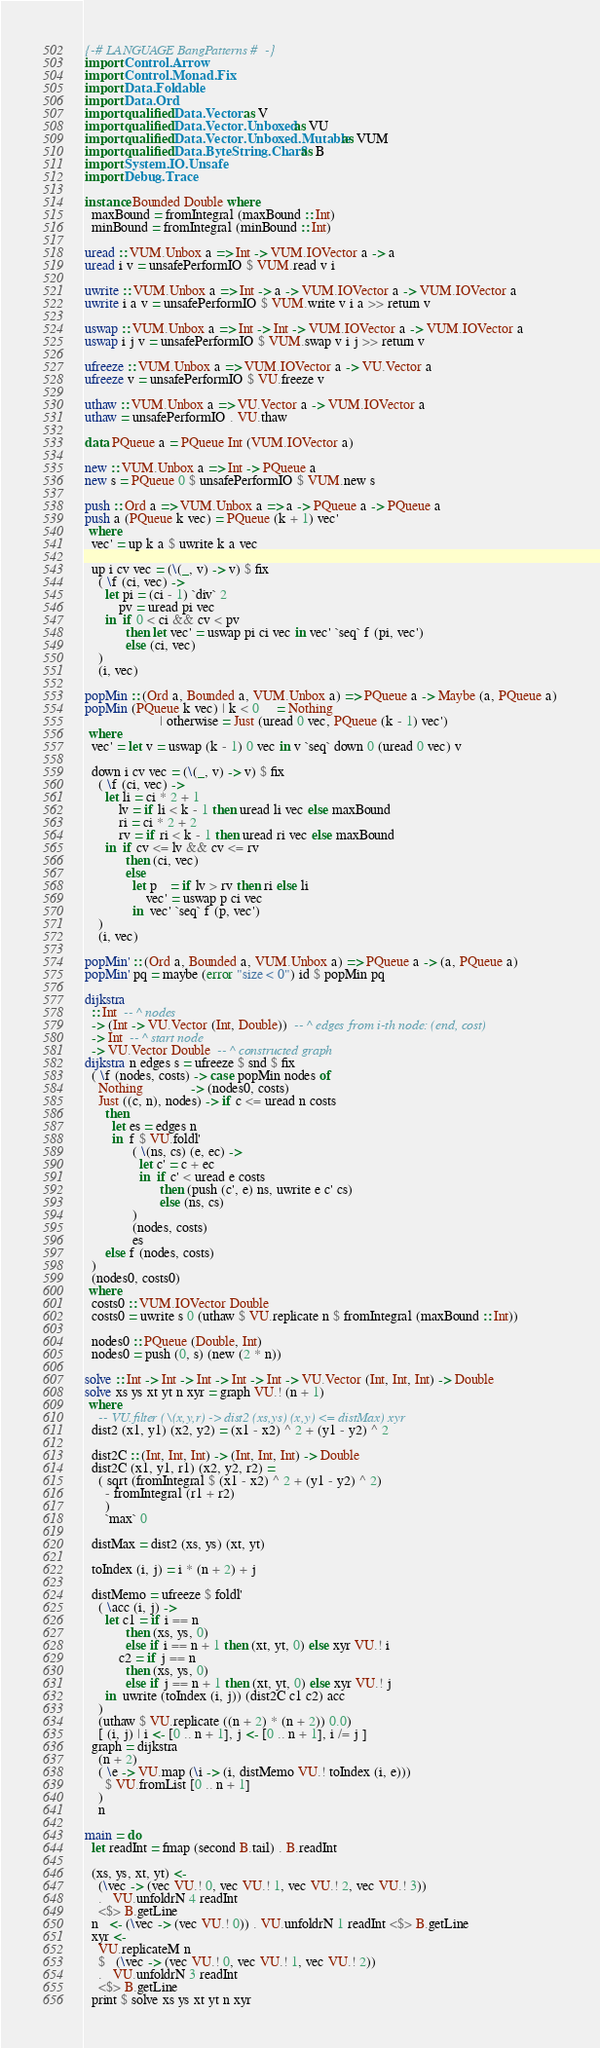<code> <loc_0><loc_0><loc_500><loc_500><_Haskell_>{-# LANGUAGE BangPatterns #-}
import Control.Arrow
import Control.Monad.Fix
import Data.Foldable
import Data.Ord
import qualified Data.Vector as V
import qualified Data.Vector.Unboxed as VU
import qualified Data.Vector.Unboxed.Mutable as VUM
import qualified Data.ByteString.Char8 as B
import System.IO.Unsafe
import Debug.Trace

instance Bounded Double where
  maxBound = fromIntegral (maxBound :: Int)
  minBound = fromIntegral (minBound :: Int)

uread :: VUM.Unbox a => Int -> VUM.IOVector a -> a
uread i v = unsafePerformIO $ VUM.read v i

uwrite :: VUM.Unbox a => Int -> a -> VUM.IOVector a -> VUM.IOVector a
uwrite i a v = unsafePerformIO $ VUM.write v i a >> return v

uswap :: VUM.Unbox a => Int -> Int -> VUM.IOVector a -> VUM.IOVector a
uswap i j v = unsafePerformIO $ VUM.swap v i j >> return v

ufreeze :: VUM.Unbox a => VUM.IOVector a -> VU.Vector a
ufreeze v = unsafePerformIO $ VU.freeze v

uthaw :: VUM.Unbox a => VU.Vector a -> VUM.IOVector a
uthaw = unsafePerformIO . VU.thaw

data PQueue a = PQueue Int (VUM.IOVector a)

new :: VUM.Unbox a => Int -> PQueue a
new s = PQueue 0 $ unsafePerformIO $ VUM.new s

push :: Ord a => VUM.Unbox a => a -> PQueue a -> PQueue a
push a (PQueue k vec) = PQueue (k + 1) vec'
 where
  vec' = up k a $ uwrite k a vec

  up i cv vec = (\(_, v) -> v) $ fix
    ( \f (ci, vec) ->
      let pi = (ci - 1) `div` 2
          pv = uread pi vec
      in  if 0 < ci && cv < pv
            then let vec' = uswap pi ci vec in vec' `seq` f (pi, vec')
            else (ci, vec)
    )
    (i, vec)

popMin :: (Ord a, Bounded a, VUM.Unbox a) => PQueue a -> Maybe (a, PQueue a)
popMin (PQueue k vec) | k < 0     = Nothing
                      | otherwise = Just (uread 0 vec, PQueue (k - 1) vec')
 where
  vec' = let v = uswap (k - 1) 0 vec in v `seq` down 0 (uread 0 vec) v

  down i cv vec = (\(_, v) -> v) $ fix
    ( \f (ci, vec) ->
      let li = ci * 2 + 1
          lv = if li < k - 1 then uread li vec else maxBound
          ri = ci * 2 + 2
          rv = if ri < k - 1 then uread ri vec else maxBound
      in  if cv <= lv && cv <= rv
            then (ci, vec)
            else
              let p    = if lv > rv then ri else li
                  vec' = uswap p ci vec
              in  vec' `seq` f (p, vec')
    )
    (i, vec)

popMin' :: (Ord a, Bounded a, VUM.Unbox a) => PQueue a -> (a, PQueue a)
popMin' pq = maybe (error "size < 0") id $ popMin pq

dijkstra
  :: Int  -- ^ nodes
  -> (Int -> VU.Vector (Int, Double))  -- ^ edges from i-th node: (end, cost)
  -> Int  -- ^ start node
  -> VU.Vector Double  -- ^ constructed graph
dijkstra n edges s = ufreeze $ snd $ fix
  ( \f (nodes, costs) -> case popMin nodes of
    Nothing              -> (nodes0, costs)
    Just ((c, n), nodes) -> if c <= uread n costs
      then
        let es = edges n
        in  f $ VU.foldl'
              ( \(ns, cs) (e, ec) ->
                let c' = c + ec
                in  if c' < uread e costs
                      then (push (c', e) ns, uwrite e c' cs)
                      else (ns, cs)
              )
              (nodes, costs)
              es
      else f (nodes, costs)
  )
  (nodes0, costs0)
 where
  costs0 :: VUM.IOVector Double
  costs0 = uwrite s 0 (uthaw $ VU.replicate n $ fromIntegral (maxBound :: Int))

  nodes0 :: PQueue (Double, Int)
  nodes0 = push (0, s) (new (2 * n))

solve :: Int -> Int -> Int -> Int -> Int -> VU.Vector (Int, Int, Int) -> Double
solve xs ys xt yt n xyr = graph VU.! (n + 1)
 where
    -- VU.filter (\(x,y,r) -> dist2 (xs,ys) (x,y) <= distMax) xyr
  dist2 (x1, y1) (x2, y2) = (x1 - x2) ^ 2 + (y1 - y2) ^ 2

  dist2C :: (Int, Int, Int) -> (Int, Int, Int) -> Double
  dist2C (x1, y1, r1) (x2, y2, r2) =
    ( sqrt (fromIntegral $ (x1 - x2) ^ 2 + (y1 - y2) ^ 2)
      - fromIntegral (r1 + r2)
      )
      `max` 0

  distMax = dist2 (xs, ys) (xt, yt)

  toIndex (i, j) = i * (n + 2) + j

  distMemo = ufreeze $ foldl'
    ( \acc (i, j) ->
      let c1 = if i == n
            then (xs, ys, 0)
            else if i == n + 1 then (xt, yt, 0) else xyr VU.! i
          c2 = if j == n
            then (xs, ys, 0)
            else if j == n + 1 then (xt, yt, 0) else xyr VU.! j
      in  uwrite (toIndex (i, j)) (dist2C c1 c2) acc
    )
    (uthaw $ VU.replicate ((n + 2) * (n + 2)) 0.0)
    [ (i, j) | i <- [0 .. n + 1], j <- [0 .. n + 1], i /= j ]
  graph = dijkstra
    (n + 2)
    ( \e -> VU.map (\i -> (i, distMemo VU.! toIndex (i, e)))
      $ VU.fromList [0 .. n + 1]
    )
    n

main = do
  let readInt = fmap (second B.tail) . B.readInt

  (xs, ys, xt, yt) <-
    (\vec -> (vec VU.! 0, vec VU.! 1, vec VU.! 2, vec VU.! 3))
    .   VU.unfoldrN 4 readInt
    <$> B.getLine
  n   <- (\vec -> (vec VU.! 0)) . VU.unfoldrN 1 readInt <$> B.getLine
  xyr <-
    VU.replicateM n
    $   (\vec -> (vec VU.! 0, vec VU.! 1, vec VU.! 2))
    .   VU.unfoldrN 3 readInt
    <$> B.getLine
  print $ solve xs ys xt yt n xyr
</code> 